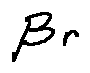<formula> <loc_0><loc_0><loc_500><loc_500>\beta r</formula> 